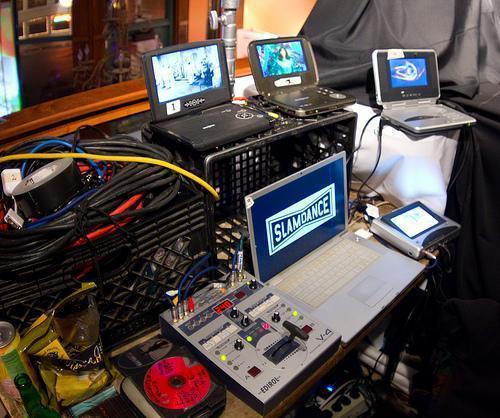How many laptops are there?
Give a very brief answer. 1. 